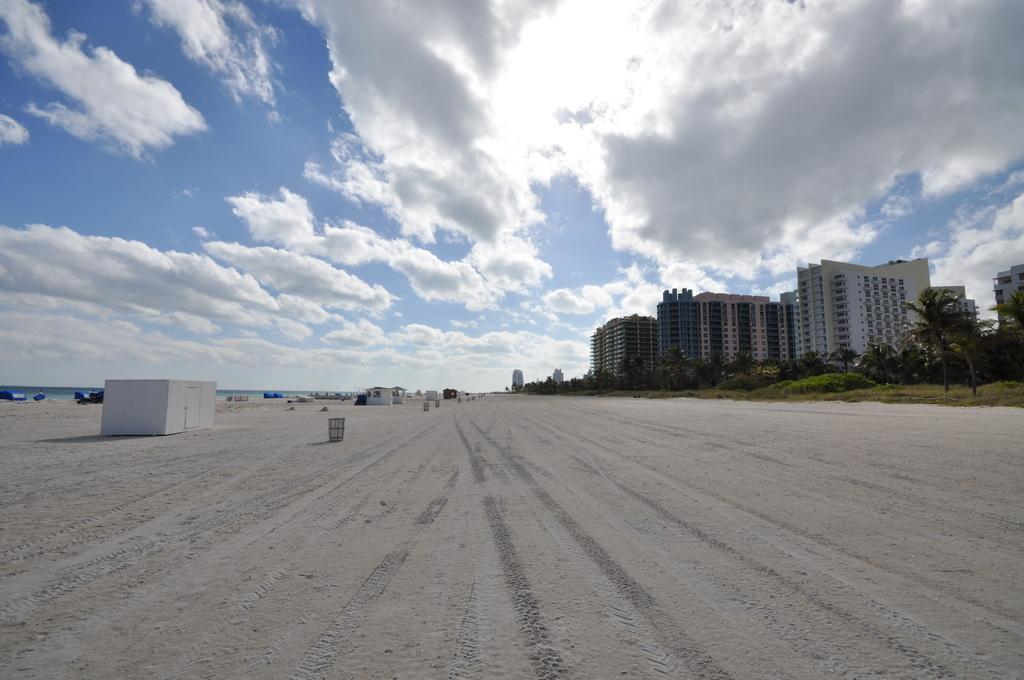What type of structures can be seen in the image? There are sheds, objects, and buildings in the image. What is on the ground in the image? There are objects on the ground in the image. What type of vegetation is present in the image? There are trees and grass in the image. What is visible in the background of the image? The sky is visible in the background of the image. What can be seen in the sky? Clouds are present in the sky. What type of root can be seen growing from the sheds in the image? There is no root growing from the sheds in the image. What type of cart is being pulled by the trees in the image? There is no cart present in the image, nor are the trees pulling anything. 